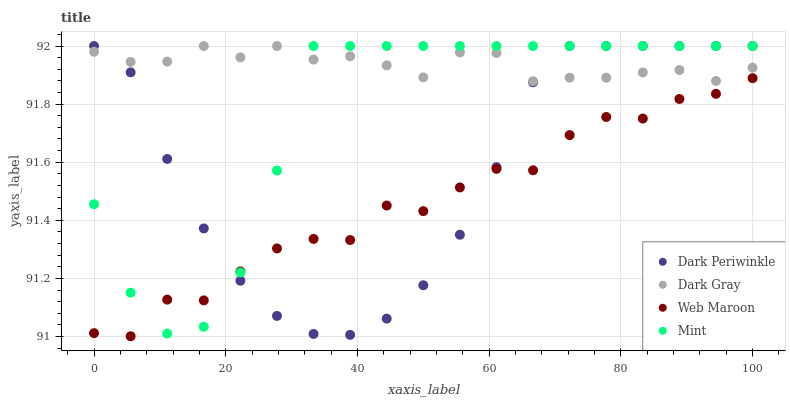Does Web Maroon have the minimum area under the curve?
Answer yes or no. Yes. Does Dark Gray have the maximum area under the curve?
Answer yes or no. Yes. Does Mint have the minimum area under the curve?
Answer yes or no. No. Does Mint have the maximum area under the curve?
Answer yes or no. No. Is Dark Gray the smoothest?
Answer yes or no. Yes. Is Web Maroon the roughest?
Answer yes or no. Yes. Is Mint the smoothest?
Answer yes or no. No. Is Mint the roughest?
Answer yes or no. No. Does Web Maroon have the lowest value?
Answer yes or no. Yes. Does Mint have the lowest value?
Answer yes or no. No. Does Dark Periwinkle have the highest value?
Answer yes or no. Yes. Does Web Maroon have the highest value?
Answer yes or no. No. Is Web Maroon less than Dark Gray?
Answer yes or no. Yes. Is Dark Gray greater than Web Maroon?
Answer yes or no. Yes. Does Mint intersect Dark Gray?
Answer yes or no. Yes. Is Mint less than Dark Gray?
Answer yes or no. No. Is Mint greater than Dark Gray?
Answer yes or no. No. Does Web Maroon intersect Dark Gray?
Answer yes or no. No. 